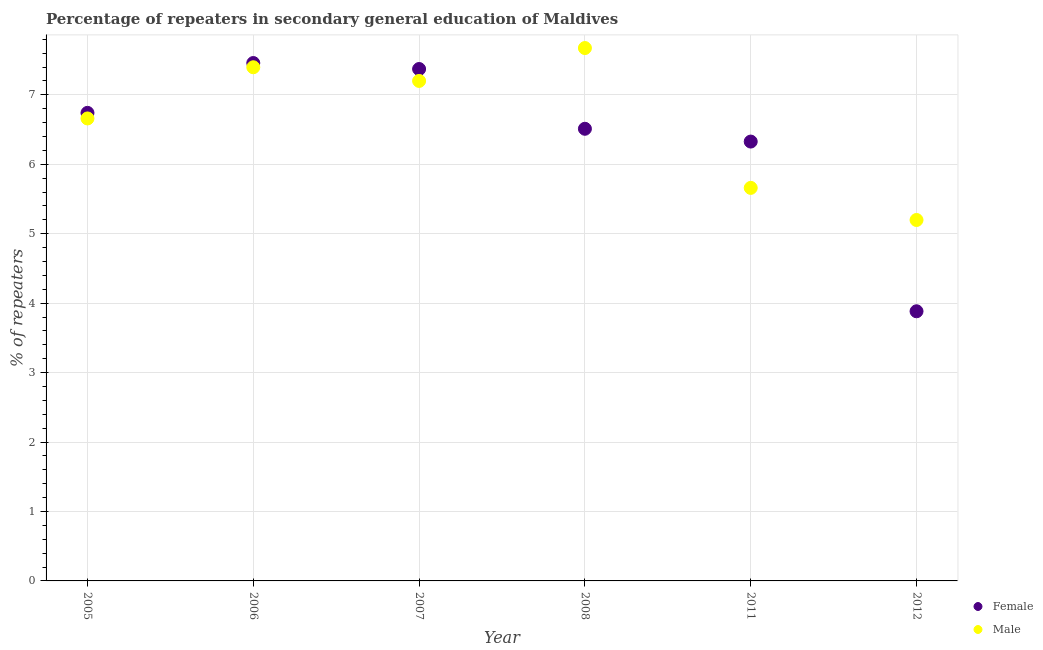Is the number of dotlines equal to the number of legend labels?
Your response must be concise. Yes. What is the percentage of male repeaters in 2011?
Keep it short and to the point. 5.66. Across all years, what is the maximum percentage of male repeaters?
Make the answer very short. 7.67. Across all years, what is the minimum percentage of male repeaters?
Give a very brief answer. 5.2. In which year was the percentage of female repeaters minimum?
Keep it short and to the point. 2012. What is the total percentage of male repeaters in the graph?
Make the answer very short. 39.79. What is the difference between the percentage of male repeaters in 2006 and that in 2007?
Provide a short and direct response. 0.2. What is the difference between the percentage of female repeaters in 2006 and the percentage of male repeaters in 2012?
Keep it short and to the point. 2.26. What is the average percentage of female repeaters per year?
Your response must be concise. 6.38. In the year 2005, what is the difference between the percentage of male repeaters and percentage of female repeaters?
Provide a succinct answer. -0.08. What is the ratio of the percentage of male repeaters in 2007 to that in 2011?
Your answer should be very brief. 1.27. Is the difference between the percentage of male repeaters in 2005 and 2011 greater than the difference between the percentage of female repeaters in 2005 and 2011?
Keep it short and to the point. Yes. What is the difference between the highest and the second highest percentage of female repeaters?
Ensure brevity in your answer.  0.09. What is the difference between the highest and the lowest percentage of female repeaters?
Provide a succinct answer. 3.57. Is the sum of the percentage of male repeaters in 2006 and 2008 greater than the maximum percentage of female repeaters across all years?
Provide a short and direct response. Yes. Is the percentage of female repeaters strictly greater than the percentage of male repeaters over the years?
Offer a terse response. No. Is the percentage of male repeaters strictly less than the percentage of female repeaters over the years?
Provide a short and direct response. No. How many years are there in the graph?
Keep it short and to the point. 6. What is the difference between two consecutive major ticks on the Y-axis?
Keep it short and to the point. 1. How many legend labels are there?
Ensure brevity in your answer.  2. What is the title of the graph?
Give a very brief answer. Percentage of repeaters in secondary general education of Maldives. Does "External balance on goods" appear as one of the legend labels in the graph?
Make the answer very short. No. What is the label or title of the X-axis?
Make the answer very short. Year. What is the label or title of the Y-axis?
Your answer should be very brief. % of repeaters. What is the % of repeaters of Female in 2005?
Your answer should be very brief. 6.74. What is the % of repeaters of Male in 2005?
Provide a succinct answer. 6.66. What is the % of repeaters in Female in 2006?
Give a very brief answer. 7.46. What is the % of repeaters of Male in 2006?
Provide a short and direct response. 7.4. What is the % of repeaters in Female in 2007?
Ensure brevity in your answer.  7.37. What is the % of repeaters in Male in 2007?
Provide a succinct answer. 7.2. What is the % of repeaters in Female in 2008?
Offer a terse response. 6.51. What is the % of repeaters in Male in 2008?
Keep it short and to the point. 7.67. What is the % of repeaters of Female in 2011?
Your answer should be very brief. 6.33. What is the % of repeaters of Male in 2011?
Keep it short and to the point. 5.66. What is the % of repeaters of Female in 2012?
Your response must be concise. 3.88. What is the % of repeaters of Male in 2012?
Ensure brevity in your answer.  5.2. Across all years, what is the maximum % of repeaters of Female?
Provide a short and direct response. 7.46. Across all years, what is the maximum % of repeaters in Male?
Your answer should be very brief. 7.67. Across all years, what is the minimum % of repeaters in Female?
Your answer should be compact. 3.88. Across all years, what is the minimum % of repeaters in Male?
Ensure brevity in your answer.  5.2. What is the total % of repeaters in Female in the graph?
Offer a terse response. 38.29. What is the total % of repeaters of Male in the graph?
Keep it short and to the point. 39.79. What is the difference between the % of repeaters of Female in 2005 and that in 2006?
Offer a very short reply. -0.72. What is the difference between the % of repeaters in Male in 2005 and that in 2006?
Give a very brief answer. -0.74. What is the difference between the % of repeaters of Female in 2005 and that in 2007?
Offer a very short reply. -0.63. What is the difference between the % of repeaters in Male in 2005 and that in 2007?
Give a very brief answer. -0.54. What is the difference between the % of repeaters of Female in 2005 and that in 2008?
Give a very brief answer. 0.23. What is the difference between the % of repeaters in Male in 2005 and that in 2008?
Keep it short and to the point. -1.01. What is the difference between the % of repeaters in Female in 2005 and that in 2011?
Make the answer very short. 0.41. What is the difference between the % of repeaters of Female in 2005 and that in 2012?
Your response must be concise. 2.86. What is the difference between the % of repeaters of Male in 2005 and that in 2012?
Offer a very short reply. 1.46. What is the difference between the % of repeaters of Female in 2006 and that in 2007?
Your answer should be very brief. 0.09. What is the difference between the % of repeaters in Male in 2006 and that in 2007?
Ensure brevity in your answer.  0.2. What is the difference between the % of repeaters of Female in 2006 and that in 2008?
Your answer should be very brief. 0.95. What is the difference between the % of repeaters of Male in 2006 and that in 2008?
Provide a short and direct response. -0.28. What is the difference between the % of repeaters in Female in 2006 and that in 2011?
Give a very brief answer. 1.13. What is the difference between the % of repeaters in Male in 2006 and that in 2011?
Offer a very short reply. 1.74. What is the difference between the % of repeaters in Female in 2006 and that in 2012?
Provide a short and direct response. 3.58. What is the difference between the % of repeaters in Male in 2006 and that in 2012?
Your answer should be compact. 2.2. What is the difference between the % of repeaters in Female in 2007 and that in 2008?
Provide a succinct answer. 0.86. What is the difference between the % of repeaters in Male in 2007 and that in 2008?
Offer a terse response. -0.47. What is the difference between the % of repeaters in Female in 2007 and that in 2011?
Provide a short and direct response. 1.04. What is the difference between the % of repeaters of Male in 2007 and that in 2011?
Give a very brief answer. 1.54. What is the difference between the % of repeaters in Female in 2007 and that in 2012?
Offer a very short reply. 3.49. What is the difference between the % of repeaters in Male in 2007 and that in 2012?
Your response must be concise. 2. What is the difference between the % of repeaters of Female in 2008 and that in 2011?
Ensure brevity in your answer.  0.18. What is the difference between the % of repeaters of Male in 2008 and that in 2011?
Give a very brief answer. 2.01. What is the difference between the % of repeaters of Female in 2008 and that in 2012?
Keep it short and to the point. 2.63. What is the difference between the % of repeaters of Male in 2008 and that in 2012?
Ensure brevity in your answer.  2.48. What is the difference between the % of repeaters in Female in 2011 and that in 2012?
Keep it short and to the point. 2.44. What is the difference between the % of repeaters in Male in 2011 and that in 2012?
Your response must be concise. 0.46. What is the difference between the % of repeaters in Female in 2005 and the % of repeaters in Male in 2006?
Make the answer very short. -0.66. What is the difference between the % of repeaters of Female in 2005 and the % of repeaters of Male in 2007?
Your response must be concise. -0.46. What is the difference between the % of repeaters of Female in 2005 and the % of repeaters of Male in 2008?
Offer a very short reply. -0.93. What is the difference between the % of repeaters in Female in 2005 and the % of repeaters in Male in 2011?
Your answer should be compact. 1.08. What is the difference between the % of repeaters of Female in 2005 and the % of repeaters of Male in 2012?
Keep it short and to the point. 1.54. What is the difference between the % of repeaters of Female in 2006 and the % of repeaters of Male in 2007?
Ensure brevity in your answer.  0.26. What is the difference between the % of repeaters in Female in 2006 and the % of repeaters in Male in 2008?
Your answer should be very brief. -0.22. What is the difference between the % of repeaters in Female in 2006 and the % of repeaters in Male in 2011?
Offer a very short reply. 1.8. What is the difference between the % of repeaters in Female in 2006 and the % of repeaters in Male in 2012?
Give a very brief answer. 2.26. What is the difference between the % of repeaters of Female in 2007 and the % of repeaters of Male in 2008?
Provide a succinct answer. -0.3. What is the difference between the % of repeaters in Female in 2007 and the % of repeaters in Male in 2011?
Keep it short and to the point. 1.71. What is the difference between the % of repeaters of Female in 2007 and the % of repeaters of Male in 2012?
Offer a very short reply. 2.17. What is the difference between the % of repeaters of Female in 2008 and the % of repeaters of Male in 2011?
Give a very brief answer. 0.85. What is the difference between the % of repeaters in Female in 2008 and the % of repeaters in Male in 2012?
Your answer should be very brief. 1.31. What is the difference between the % of repeaters of Female in 2011 and the % of repeaters of Male in 2012?
Ensure brevity in your answer.  1.13. What is the average % of repeaters of Female per year?
Your answer should be compact. 6.38. What is the average % of repeaters in Male per year?
Give a very brief answer. 6.63. In the year 2005, what is the difference between the % of repeaters of Female and % of repeaters of Male?
Keep it short and to the point. 0.08. In the year 2006, what is the difference between the % of repeaters of Female and % of repeaters of Male?
Provide a succinct answer. 0.06. In the year 2007, what is the difference between the % of repeaters of Female and % of repeaters of Male?
Offer a very short reply. 0.17. In the year 2008, what is the difference between the % of repeaters of Female and % of repeaters of Male?
Give a very brief answer. -1.16. In the year 2011, what is the difference between the % of repeaters of Female and % of repeaters of Male?
Provide a succinct answer. 0.67. In the year 2012, what is the difference between the % of repeaters of Female and % of repeaters of Male?
Offer a terse response. -1.31. What is the ratio of the % of repeaters of Female in 2005 to that in 2006?
Keep it short and to the point. 0.9. What is the ratio of the % of repeaters in Male in 2005 to that in 2006?
Your answer should be compact. 0.9. What is the ratio of the % of repeaters of Female in 2005 to that in 2007?
Provide a succinct answer. 0.91. What is the ratio of the % of repeaters in Male in 2005 to that in 2007?
Make the answer very short. 0.93. What is the ratio of the % of repeaters of Female in 2005 to that in 2008?
Give a very brief answer. 1.04. What is the ratio of the % of repeaters of Male in 2005 to that in 2008?
Give a very brief answer. 0.87. What is the ratio of the % of repeaters in Female in 2005 to that in 2011?
Your answer should be compact. 1.07. What is the ratio of the % of repeaters in Male in 2005 to that in 2011?
Offer a terse response. 1.18. What is the ratio of the % of repeaters in Female in 2005 to that in 2012?
Make the answer very short. 1.74. What is the ratio of the % of repeaters in Male in 2005 to that in 2012?
Keep it short and to the point. 1.28. What is the ratio of the % of repeaters in Female in 2006 to that in 2007?
Give a very brief answer. 1.01. What is the ratio of the % of repeaters of Male in 2006 to that in 2007?
Make the answer very short. 1.03. What is the ratio of the % of repeaters in Female in 2006 to that in 2008?
Provide a short and direct response. 1.15. What is the ratio of the % of repeaters of Male in 2006 to that in 2008?
Your answer should be very brief. 0.96. What is the ratio of the % of repeaters in Female in 2006 to that in 2011?
Provide a short and direct response. 1.18. What is the ratio of the % of repeaters of Male in 2006 to that in 2011?
Your answer should be very brief. 1.31. What is the ratio of the % of repeaters of Female in 2006 to that in 2012?
Your answer should be compact. 1.92. What is the ratio of the % of repeaters in Male in 2006 to that in 2012?
Make the answer very short. 1.42. What is the ratio of the % of repeaters in Female in 2007 to that in 2008?
Keep it short and to the point. 1.13. What is the ratio of the % of repeaters in Male in 2007 to that in 2008?
Provide a short and direct response. 0.94. What is the ratio of the % of repeaters in Female in 2007 to that in 2011?
Give a very brief answer. 1.17. What is the ratio of the % of repeaters in Male in 2007 to that in 2011?
Your answer should be compact. 1.27. What is the ratio of the % of repeaters of Female in 2007 to that in 2012?
Offer a terse response. 1.9. What is the ratio of the % of repeaters of Male in 2007 to that in 2012?
Offer a very short reply. 1.39. What is the ratio of the % of repeaters in Female in 2008 to that in 2011?
Your response must be concise. 1.03. What is the ratio of the % of repeaters in Male in 2008 to that in 2011?
Ensure brevity in your answer.  1.36. What is the ratio of the % of repeaters of Female in 2008 to that in 2012?
Ensure brevity in your answer.  1.68. What is the ratio of the % of repeaters of Male in 2008 to that in 2012?
Your answer should be compact. 1.48. What is the ratio of the % of repeaters in Female in 2011 to that in 2012?
Make the answer very short. 1.63. What is the ratio of the % of repeaters of Male in 2011 to that in 2012?
Provide a short and direct response. 1.09. What is the difference between the highest and the second highest % of repeaters of Female?
Your answer should be compact. 0.09. What is the difference between the highest and the second highest % of repeaters of Male?
Ensure brevity in your answer.  0.28. What is the difference between the highest and the lowest % of repeaters in Female?
Keep it short and to the point. 3.58. What is the difference between the highest and the lowest % of repeaters of Male?
Provide a succinct answer. 2.48. 